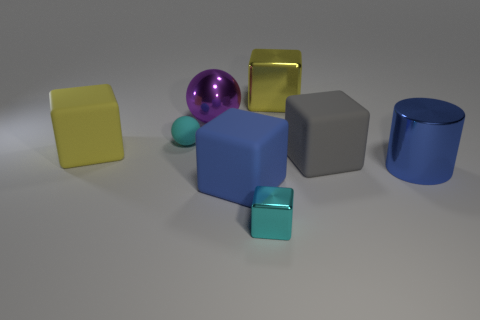The blue object that is the same shape as the big gray matte object is what size?
Provide a short and direct response. Large. What number of big green blocks are made of the same material as the large blue block?
Offer a terse response. 0. How many big blue blocks are left of the cyan thing on the left side of the large purple metal ball?
Make the answer very short. 0. There is a small cyan metal block; are there any big yellow rubber things to the right of it?
Give a very brief answer. No. There is a cyan thing that is on the left side of the big blue cube; is it the same shape as the big yellow matte object?
Offer a very short reply. No. What material is the other cube that is the same color as the big metallic block?
Provide a succinct answer. Rubber. How many large blocks have the same color as the tiny cube?
Your answer should be very brief. 0. There is a tiny thing that is behind the tiny cyan object that is in front of the large yellow matte object; what is its shape?
Give a very brief answer. Sphere. Is there a large purple metal thing of the same shape as the cyan matte thing?
Provide a succinct answer. Yes. Does the big sphere have the same color as the small thing in front of the cyan ball?
Your answer should be compact. No. 